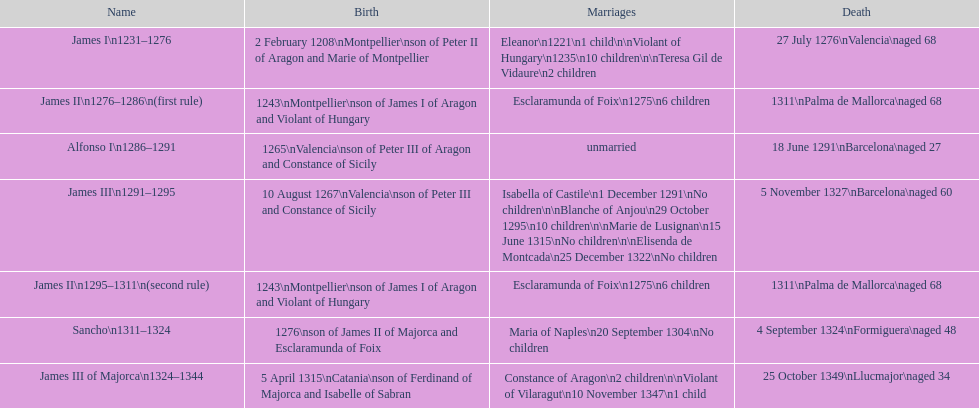Out of these kings and queens, how many did not live to see the age of 65? 4. 